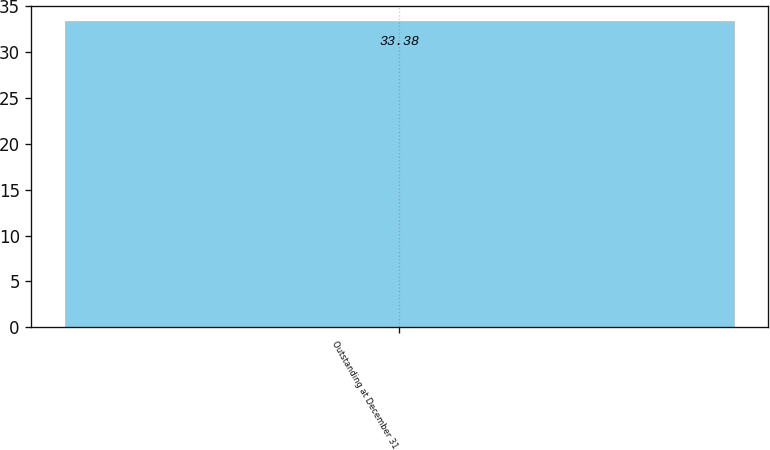<chart> <loc_0><loc_0><loc_500><loc_500><bar_chart><fcel>Outstanding at December 31<nl><fcel>33.38<nl></chart> 